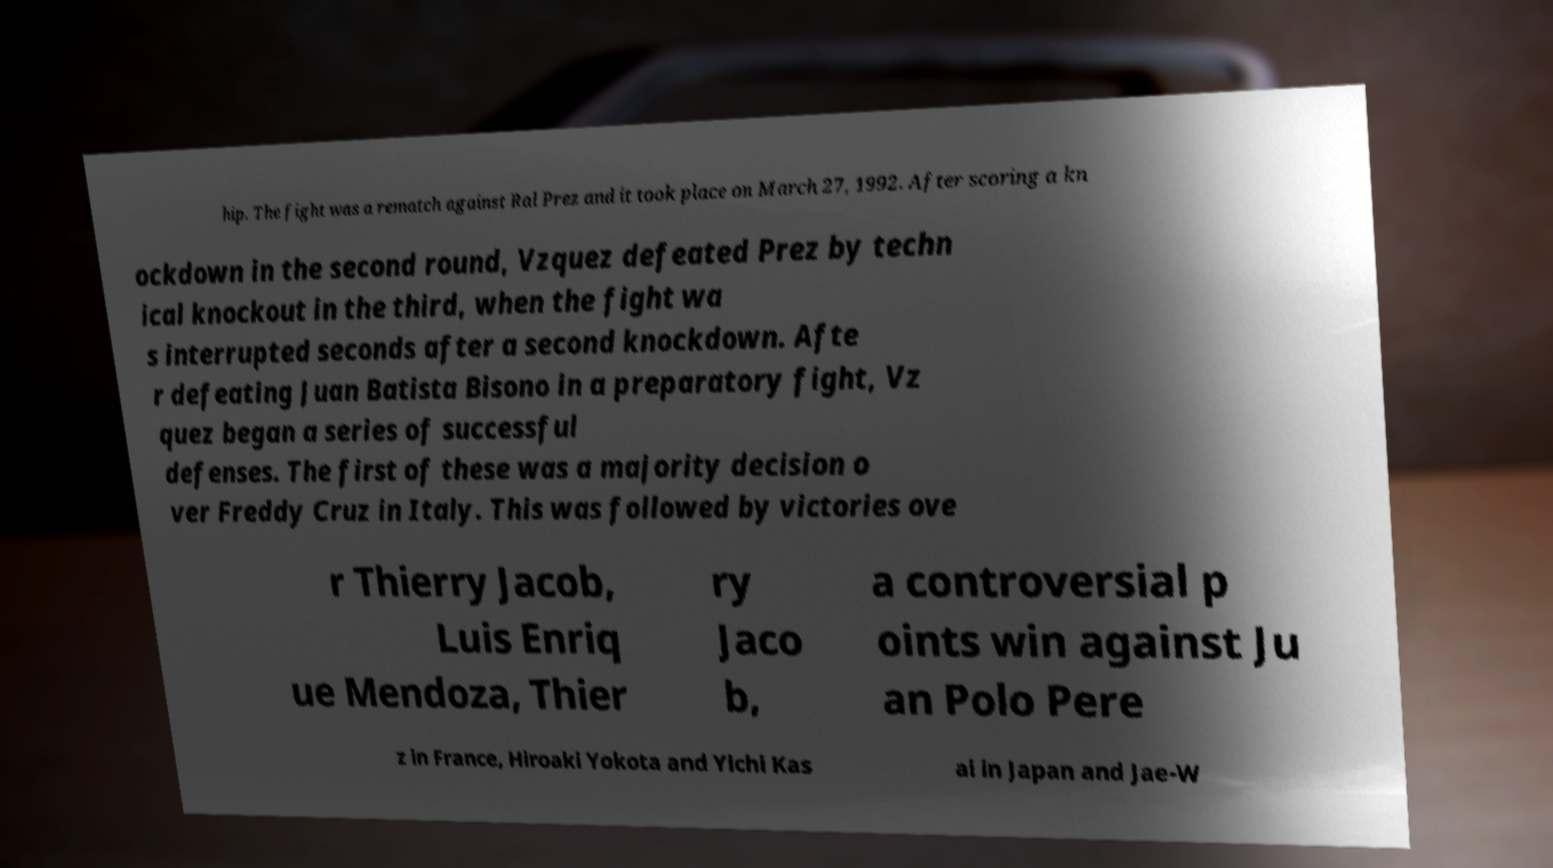Please identify and transcribe the text found in this image. hip. The fight was a rematch against Ral Prez and it took place on March 27, 1992. After scoring a kn ockdown in the second round, Vzquez defeated Prez by techn ical knockout in the third, when the fight wa s interrupted seconds after a second knockdown. Afte r defeating Juan Batista Bisono in a preparatory fight, Vz quez began a series of successful defenses. The first of these was a majority decision o ver Freddy Cruz in Italy. This was followed by victories ove r Thierry Jacob, Luis Enriq ue Mendoza, Thier ry Jaco b, a controversial p oints win against Ju an Polo Pere z in France, Hiroaki Yokota and Yichi Kas ai in Japan and Jae-W 